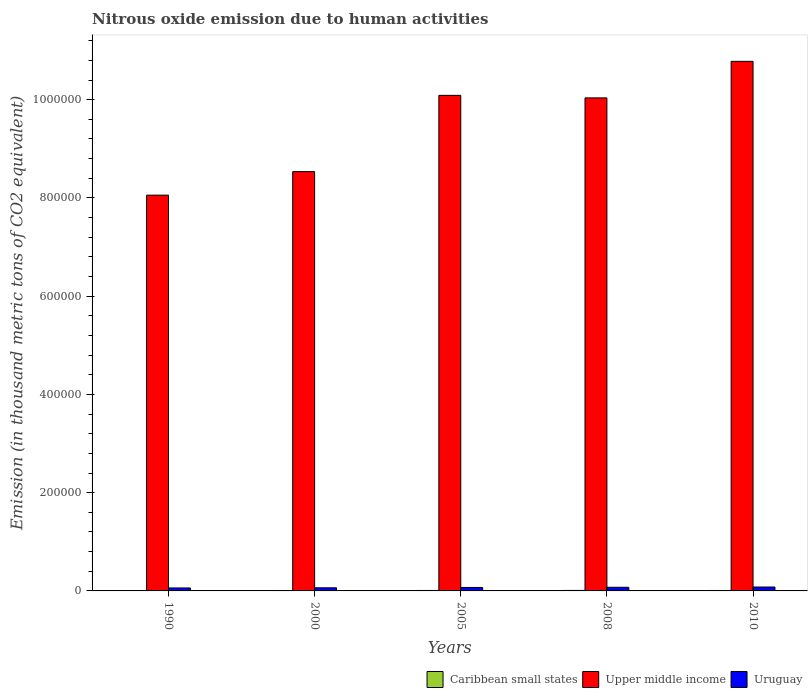How many different coloured bars are there?
Offer a very short reply. 3. How many groups of bars are there?
Your answer should be very brief. 5. Are the number of bars on each tick of the X-axis equal?
Make the answer very short. Yes. How many bars are there on the 5th tick from the left?
Your answer should be very brief. 3. How many bars are there on the 3rd tick from the right?
Offer a very short reply. 3. In how many cases, is the number of bars for a given year not equal to the number of legend labels?
Give a very brief answer. 0. What is the amount of nitrous oxide emitted in Uruguay in 1990?
Your response must be concise. 6054.9. Across all years, what is the maximum amount of nitrous oxide emitted in Uruguay?
Your answer should be compact. 7946.5. Across all years, what is the minimum amount of nitrous oxide emitted in Caribbean small states?
Provide a succinct answer. 699.1. In which year was the amount of nitrous oxide emitted in Uruguay maximum?
Your answer should be compact. 2010. What is the total amount of nitrous oxide emitted in Uruguay in the graph?
Your response must be concise. 3.48e+04. What is the difference between the amount of nitrous oxide emitted in Upper middle income in 1990 and that in 2010?
Offer a very short reply. -2.72e+05. What is the difference between the amount of nitrous oxide emitted in Caribbean small states in 2010 and the amount of nitrous oxide emitted in Upper middle income in 2005?
Keep it short and to the point. -1.01e+06. What is the average amount of nitrous oxide emitted in Caribbean small states per year?
Provide a succinct answer. 882.52. In the year 2005, what is the difference between the amount of nitrous oxide emitted in Caribbean small states and amount of nitrous oxide emitted in Uruguay?
Ensure brevity in your answer.  -6109.6. What is the ratio of the amount of nitrous oxide emitted in Uruguay in 2008 to that in 2010?
Ensure brevity in your answer.  0.93. What is the difference between the highest and the second highest amount of nitrous oxide emitted in Upper middle income?
Your answer should be compact. 6.92e+04. What is the difference between the highest and the lowest amount of nitrous oxide emitted in Upper middle income?
Make the answer very short. 2.72e+05. Is the sum of the amount of nitrous oxide emitted in Uruguay in 1990 and 2010 greater than the maximum amount of nitrous oxide emitted in Caribbean small states across all years?
Offer a very short reply. Yes. What does the 1st bar from the left in 2005 represents?
Give a very brief answer. Caribbean small states. What does the 2nd bar from the right in 2010 represents?
Provide a succinct answer. Upper middle income. How many years are there in the graph?
Give a very brief answer. 5. Are the values on the major ticks of Y-axis written in scientific E-notation?
Give a very brief answer. No. Does the graph contain grids?
Give a very brief answer. No. What is the title of the graph?
Make the answer very short. Nitrous oxide emission due to human activities. What is the label or title of the X-axis?
Your answer should be very brief. Years. What is the label or title of the Y-axis?
Provide a short and direct response. Emission (in thousand metric tons of CO2 equivalent). What is the Emission (in thousand metric tons of CO2 equivalent) of Caribbean small states in 1990?
Your answer should be very brief. 699.1. What is the Emission (in thousand metric tons of CO2 equivalent) of Upper middle income in 1990?
Your answer should be compact. 8.06e+05. What is the Emission (in thousand metric tons of CO2 equivalent) in Uruguay in 1990?
Provide a succinct answer. 6054.9. What is the Emission (in thousand metric tons of CO2 equivalent) of Caribbean small states in 2000?
Provide a short and direct response. 867.7. What is the Emission (in thousand metric tons of CO2 equivalent) in Upper middle income in 2000?
Provide a short and direct response. 8.54e+05. What is the Emission (in thousand metric tons of CO2 equivalent) of Uruguay in 2000?
Give a very brief answer. 6333.8. What is the Emission (in thousand metric tons of CO2 equivalent) of Caribbean small states in 2005?
Ensure brevity in your answer.  923.3. What is the Emission (in thousand metric tons of CO2 equivalent) of Upper middle income in 2005?
Your answer should be very brief. 1.01e+06. What is the Emission (in thousand metric tons of CO2 equivalent) of Uruguay in 2005?
Provide a short and direct response. 7032.9. What is the Emission (in thousand metric tons of CO2 equivalent) of Caribbean small states in 2008?
Give a very brief answer. 1003.4. What is the Emission (in thousand metric tons of CO2 equivalent) in Upper middle income in 2008?
Keep it short and to the point. 1.00e+06. What is the Emission (in thousand metric tons of CO2 equivalent) of Uruguay in 2008?
Your answer should be very brief. 7408. What is the Emission (in thousand metric tons of CO2 equivalent) in Caribbean small states in 2010?
Provide a succinct answer. 919.1. What is the Emission (in thousand metric tons of CO2 equivalent) of Upper middle income in 2010?
Give a very brief answer. 1.08e+06. What is the Emission (in thousand metric tons of CO2 equivalent) of Uruguay in 2010?
Give a very brief answer. 7946.5. Across all years, what is the maximum Emission (in thousand metric tons of CO2 equivalent) of Caribbean small states?
Your answer should be very brief. 1003.4. Across all years, what is the maximum Emission (in thousand metric tons of CO2 equivalent) in Upper middle income?
Ensure brevity in your answer.  1.08e+06. Across all years, what is the maximum Emission (in thousand metric tons of CO2 equivalent) of Uruguay?
Provide a succinct answer. 7946.5. Across all years, what is the minimum Emission (in thousand metric tons of CO2 equivalent) of Caribbean small states?
Keep it short and to the point. 699.1. Across all years, what is the minimum Emission (in thousand metric tons of CO2 equivalent) in Upper middle income?
Your response must be concise. 8.06e+05. Across all years, what is the minimum Emission (in thousand metric tons of CO2 equivalent) in Uruguay?
Provide a succinct answer. 6054.9. What is the total Emission (in thousand metric tons of CO2 equivalent) in Caribbean small states in the graph?
Provide a succinct answer. 4412.6. What is the total Emission (in thousand metric tons of CO2 equivalent) of Upper middle income in the graph?
Provide a short and direct response. 4.75e+06. What is the total Emission (in thousand metric tons of CO2 equivalent) in Uruguay in the graph?
Your answer should be very brief. 3.48e+04. What is the difference between the Emission (in thousand metric tons of CO2 equivalent) in Caribbean small states in 1990 and that in 2000?
Provide a short and direct response. -168.6. What is the difference between the Emission (in thousand metric tons of CO2 equivalent) in Upper middle income in 1990 and that in 2000?
Keep it short and to the point. -4.79e+04. What is the difference between the Emission (in thousand metric tons of CO2 equivalent) in Uruguay in 1990 and that in 2000?
Your answer should be compact. -278.9. What is the difference between the Emission (in thousand metric tons of CO2 equivalent) of Caribbean small states in 1990 and that in 2005?
Make the answer very short. -224.2. What is the difference between the Emission (in thousand metric tons of CO2 equivalent) in Upper middle income in 1990 and that in 2005?
Offer a very short reply. -2.03e+05. What is the difference between the Emission (in thousand metric tons of CO2 equivalent) of Uruguay in 1990 and that in 2005?
Your response must be concise. -978. What is the difference between the Emission (in thousand metric tons of CO2 equivalent) in Caribbean small states in 1990 and that in 2008?
Provide a short and direct response. -304.3. What is the difference between the Emission (in thousand metric tons of CO2 equivalent) in Upper middle income in 1990 and that in 2008?
Keep it short and to the point. -1.98e+05. What is the difference between the Emission (in thousand metric tons of CO2 equivalent) of Uruguay in 1990 and that in 2008?
Keep it short and to the point. -1353.1. What is the difference between the Emission (in thousand metric tons of CO2 equivalent) in Caribbean small states in 1990 and that in 2010?
Your answer should be compact. -220. What is the difference between the Emission (in thousand metric tons of CO2 equivalent) in Upper middle income in 1990 and that in 2010?
Offer a very short reply. -2.72e+05. What is the difference between the Emission (in thousand metric tons of CO2 equivalent) in Uruguay in 1990 and that in 2010?
Give a very brief answer. -1891.6. What is the difference between the Emission (in thousand metric tons of CO2 equivalent) in Caribbean small states in 2000 and that in 2005?
Give a very brief answer. -55.6. What is the difference between the Emission (in thousand metric tons of CO2 equivalent) in Upper middle income in 2000 and that in 2005?
Provide a succinct answer. -1.55e+05. What is the difference between the Emission (in thousand metric tons of CO2 equivalent) in Uruguay in 2000 and that in 2005?
Provide a short and direct response. -699.1. What is the difference between the Emission (in thousand metric tons of CO2 equivalent) in Caribbean small states in 2000 and that in 2008?
Keep it short and to the point. -135.7. What is the difference between the Emission (in thousand metric tons of CO2 equivalent) in Upper middle income in 2000 and that in 2008?
Your answer should be very brief. -1.50e+05. What is the difference between the Emission (in thousand metric tons of CO2 equivalent) of Uruguay in 2000 and that in 2008?
Make the answer very short. -1074.2. What is the difference between the Emission (in thousand metric tons of CO2 equivalent) in Caribbean small states in 2000 and that in 2010?
Your response must be concise. -51.4. What is the difference between the Emission (in thousand metric tons of CO2 equivalent) of Upper middle income in 2000 and that in 2010?
Your answer should be very brief. -2.24e+05. What is the difference between the Emission (in thousand metric tons of CO2 equivalent) in Uruguay in 2000 and that in 2010?
Give a very brief answer. -1612.7. What is the difference between the Emission (in thousand metric tons of CO2 equivalent) of Caribbean small states in 2005 and that in 2008?
Keep it short and to the point. -80.1. What is the difference between the Emission (in thousand metric tons of CO2 equivalent) in Upper middle income in 2005 and that in 2008?
Your response must be concise. 5159.9. What is the difference between the Emission (in thousand metric tons of CO2 equivalent) in Uruguay in 2005 and that in 2008?
Your answer should be very brief. -375.1. What is the difference between the Emission (in thousand metric tons of CO2 equivalent) of Upper middle income in 2005 and that in 2010?
Your answer should be compact. -6.92e+04. What is the difference between the Emission (in thousand metric tons of CO2 equivalent) in Uruguay in 2005 and that in 2010?
Ensure brevity in your answer.  -913.6. What is the difference between the Emission (in thousand metric tons of CO2 equivalent) of Caribbean small states in 2008 and that in 2010?
Your answer should be compact. 84.3. What is the difference between the Emission (in thousand metric tons of CO2 equivalent) of Upper middle income in 2008 and that in 2010?
Provide a short and direct response. -7.44e+04. What is the difference between the Emission (in thousand metric tons of CO2 equivalent) of Uruguay in 2008 and that in 2010?
Offer a very short reply. -538.5. What is the difference between the Emission (in thousand metric tons of CO2 equivalent) in Caribbean small states in 1990 and the Emission (in thousand metric tons of CO2 equivalent) in Upper middle income in 2000?
Keep it short and to the point. -8.53e+05. What is the difference between the Emission (in thousand metric tons of CO2 equivalent) in Caribbean small states in 1990 and the Emission (in thousand metric tons of CO2 equivalent) in Uruguay in 2000?
Make the answer very short. -5634.7. What is the difference between the Emission (in thousand metric tons of CO2 equivalent) of Upper middle income in 1990 and the Emission (in thousand metric tons of CO2 equivalent) of Uruguay in 2000?
Your response must be concise. 7.99e+05. What is the difference between the Emission (in thousand metric tons of CO2 equivalent) in Caribbean small states in 1990 and the Emission (in thousand metric tons of CO2 equivalent) in Upper middle income in 2005?
Offer a very short reply. -1.01e+06. What is the difference between the Emission (in thousand metric tons of CO2 equivalent) in Caribbean small states in 1990 and the Emission (in thousand metric tons of CO2 equivalent) in Uruguay in 2005?
Your response must be concise. -6333.8. What is the difference between the Emission (in thousand metric tons of CO2 equivalent) in Upper middle income in 1990 and the Emission (in thousand metric tons of CO2 equivalent) in Uruguay in 2005?
Your answer should be very brief. 7.99e+05. What is the difference between the Emission (in thousand metric tons of CO2 equivalent) of Caribbean small states in 1990 and the Emission (in thousand metric tons of CO2 equivalent) of Upper middle income in 2008?
Your answer should be compact. -1.00e+06. What is the difference between the Emission (in thousand metric tons of CO2 equivalent) in Caribbean small states in 1990 and the Emission (in thousand metric tons of CO2 equivalent) in Uruguay in 2008?
Provide a succinct answer. -6708.9. What is the difference between the Emission (in thousand metric tons of CO2 equivalent) in Upper middle income in 1990 and the Emission (in thousand metric tons of CO2 equivalent) in Uruguay in 2008?
Your response must be concise. 7.98e+05. What is the difference between the Emission (in thousand metric tons of CO2 equivalent) in Caribbean small states in 1990 and the Emission (in thousand metric tons of CO2 equivalent) in Upper middle income in 2010?
Provide a succinct answer. -1.08e+06. What is the difference between the Emission (in thousand metric tons of CO2 equivalent) of Caribbean small states in 1990 and the Emission (in thousand metric tons of CO2 equivalent) of Uruguay in 2010?
Provide a succinct answer. -7247.4. What is the difference between the Emission (in thousand metric tons of CO2 equivalent) in Upper middle income in 1990 and the Emission (in thousand metric tons of CO2 equivalent) in Uruguay in 2010?
Keep it short and to the point. 7.98e+05. What is the difference between the Emission (in thousand metric tons of CO2 equivalent) in Caribbean small states in 2000 and the Emission (in thousand metric tons of CO2 equivalent) in Upper middle income in 2005?
Offer a very short reply. -1.01e+06. What is the difference between the Emission (in thousand metric tons of CO2 equivalent) of Caribbean small states in 2000 and the Emission (in thousand metric tons of CO2 equivalent) of Uruguay in 2005?
Provide a succinct answer. -6165.2. What is the difference between the Emission (in thousand metric tons of CO2 equivalent) in Upper middle income in 2000 and the Emission (in thousand metric tons of CO2 equivalent) in Uruguay in 2005?
Keep it short and to the point. 8.47e+05. What is the difference between the Emission (in thousand metric tons of CO2 equivalent) in Caribbean small states in 2000 and the Emission (in thousand metric tons of CO2 equivalent) in Upper middle income in 2008?
Your answer should be very brief. -1.00e+06. What is the difference between the Emission (in thousand metric tons of CO2 equivalent) in Caribbean small states in 2000 and the Emission (in thousand metric tons of CO2 equivalent) in Uruguay in 2008?
Provide a short and direct response. -6540.3. What is the difference between the Emission (in thousand metric tons of CO2 equivalent) in Upper middle income in 2000 and the Emission (in thousand metric tons of CO2 equivalent) in Uruguay in 2008?
Provide a short and direct response. 8.46e+05. What is the difference between the Emission (in thousand metric tons of CO2 equivalent) of Caribbean small states in 2000 and the Emission (in thousand metric tons of CO2 equivalent) of Upper middle income in 2010?
Your response must be concise. -1.08e+06. What is the difference between the Emission (in thousand metric tons of CO2 equivalent) in Caribbean small states in 2000 and the Emission (in thousand metric tons of CO2 equivalent) in Uruguay in 2010?
Your answer should be very brief. -7078.8. What is the difference between the Emission (in thousand metric tons of CO2 equivalent) in Upper middle income in 2000 and the Emission (in thousand metric tons of CO2 equivalent) in Uruguay in 2010?
Give a very brief answer. 8.46e+05. What is the difference between the Emission (in thousand metric tons of CO2 equivalent) in Caribbean small states in 2005 and the Emission (in thousand metric tons of CO2 equivalent) in Upper middle income in 2008?
Provide a succinct answer. -1.00e+06. What is the difference between the Emission (in thousand metric tons of CO2 equivalent) in Caribbean small states in 2005 and the Emission (in thousand metric tons of CO2 equivalent) in Uruguay in 2008?
Your answer should be compact. -6484.7. What is the difference between the Emission (in thousand metric tons of CO2 equivalent) in Upper middle income in 2005 and the Emission (in thousand metric tons of CO2 equivalent) in Uruguay in 2008?
Provide a short and direct response. 1.00e+06. What is the difference between the Emission (in thousand metric tons of CO2 equivalent) in Caribbean small states in 2005 and the Emission (in thousand metric tons of CO2 equivalent) in Upper middle income in 2010?
Your answer should be very brief. -1.08e+06. What is the difference between the Emission (in thousand metric tons of CO2 equivalent) in Caribbean small states in 2005 and the Emission (in thousand metric tons of CO2 equivalent) in Uruguay in 2010?
Make the answer very short. -7023.2. What is the difference between the Emission (in thousand metric tons of CO2 equivalent) in Upper middle income in 2005 and the Emission (in thousand metric tons of CO2 equivalent) in Uruguay in 2010?
Keep it short and to the point. 1.00e+06. What is the difference between the Emission (in thousand metric tons of CO2 equivalent) of Caribbean small states in 2008 and the Emission (in thousand metric tons of CO2 equivalent) of Upper middle income in 2010?
Offer a very short reply. -1.08e+06. What is the difference between the Emission (in thousand metric tons of CO2 equivalent) in Caribbean small states in 2008 and the Emission (in thousand metric tons of CO2 equivalent) in Uruguay in 2010?
Ensure brevity in your answer.  -6943.1. What is the difference between the Emission (in thousand metric tons of CO2 equivalent) in Upper middle income in 2008 and the Emission (in thousand metric tons of CO2 equivalent) in Uruguay in 2010?
Your answer should be very brief. 9.96e+05. What is the average Emission (in thousand metric tons of CO2 equivalent) of Caribbean small states per year?
Keep it short and to the point. 882.52. What is the average Emission (in thousand metric tons of CO2 equivalent) in Upper middle income per year?
Offer a terse response. 9.50e+05. What is the average Emission (in thousand metric tons of CO2 equivalent) of Uruguay per year?
Offer a terse response. 6955.22. In the year 1990, what is the difference between the Emission (in thousand metric tons of CO2 equivalent) of Caribbean small states and Emission (in thousand metric tons of CO2 equivalent) of Upper middle income?
Your answer should be compact. -8.05e+05. In the year 1990, what is the difference between the Emission (in thousand metric tons of CO2 equivalent) of Caribbean small states and Emission (in thousand metric tons of CO2 equivalent) of Uruguay?
Keep it short and to the point. -5355.8. In the year 1990, what is the difference between the Emission (in thousand metric tons of CO2 equivalent) in Upper middle income and Emission (in thousand metric tons of CO2 equivalent) in Uruguay?
Keep it short and to the point. 8.00e+05. In the year 2000, what is the difference between the Emission (in thousand metric tons of CO2 equivalent) of Caribbean small states and Emission (in thousand metric tons of CO2 equivalent) of Upper middle income?
Give a very brief answer. -8.53e+05. In the year 2000, what is the difference between the Emission (in thousand metric tons of CO2 equivalent) of Caribbean small states and Emission (in thousand metric tons of CO2 equivalent) of Uruguay?
Provide a succinct answer. -5466.1. In the year 2000, what is the difference between the Emission (in thousand metric tons of CO2 equivalent) of Upper middle income and Emission (in thousand metric tons of CO2 equivalent) of Uruguay?
Your response must be concise. 8.47e+05. In the year 2005, what is the difference between the Emission (in thousand metric tons of CO2 equivalent) in Caribbean small states and Emission (in thousand metric tons of CO2 equivalent) in Upper middle income?
Offer a very short reply. -1.01e+06. In the year 2005, what is the difference between the Emission (in thousand metric tons of CO2 equivalent) of Caribbean small states and Emission (in thousand metric tons of CO2 equivalent) of Uruguay?
Ensure brevity in your answer.  -6109.6. In the year 2005, what is the difference between the Emission (in thousand metric tons of CO2 equivalent) of Upper middle income and Emission (in thousand metric tons of CO2 equivalent) of Uruguay?
Ensure brevity in your answer.  1.00e+06. In the year 2008, what is the difference between the Emission (in thousand metric tons of CO2 equivalent) in Caribbean small states and Emission (in thousand metric tons of CO2 equivalent) in Upper middle income?
Offer a very short reply. -1.00e+06. In the year 2008, what is the difference between the Emission (in thousand metric tons of CO2 equivalent) in Caribbean small states and Emission (in thousand metric tons of CO2 equivalent) in Uruguay?
Offer a terse response. -6404.6. In the year 2008, what is the difference between the Emission (in thousand metric tons of CO2 equivalent) of Upper middle income and Emission (in thousand metric tons of CO2 equivalent) of Uruguay?
Your response must be concise. 9.96e+05. In the year 2010, what is the difference between the Emission (in thousand metric tons of CO2 equivalent) of Caribbean small states and Emission (in thousand metric tons of CO2 equivalent) of Upper middle income?
Your response must be concise. -1.08e+06. In the year 2010, what is the difference between the Emission (in thousand metric tons of CO2 equivalent) in Caribbean small states and Emission (in thousand metric tons of CO2 equivalent) in Uruguay?
Offer a very short reply. -7027.4. In the year 2010, what is the difference between the Emission (in thousand metric tons of CO2 equivalent) in Upper middle income and Emission (in thousand metric tons of CO2 equivalent) in Uruguay?
Your response must be concise. 1.07e+06. What is the ratio of the Emission (in thousand metric tons of CO2 equivalent) in Caribbean small states in 1990 to that in 2000?
Ensure brevity in your answer.  0.81. What is the ratio of the Emission (in thousand metric tons of CO2 equivalent) in Upper middle income in 1990 to that in 2000?
Give a very brief answer. 0.94. What is the ratio of the Emission (in thousand metric tons of CO2 equivalent) in Uruguay in 1990 to that in 2000?
Offer a very short reply. 0.96. What is the ratio of the Emission (in thousand metric tons of CO2 equivalent) in Caribbean small states in 1990 to that in 2005?
Your response must be concise. 0.76. What is the ratio of the Emission (in thousand metric tons of CO2 equivalent) of Upper middle income in 1990 to that in 2005?
Your answer should be compact. 0.8. What is the ratio of the Emission (in thousand metric tons of CO2 equivalent) in Uruguay in 1990 to that in 2005?
Offer a very short reply. 0.86. What is the ratio of the Emission (in thousand metric tons of CO2 equivalent) in Caribbean small states in 1990 to that in 2008?
Provide a short and direct response. 0.7. What is the ratio of the Emission (in thousand metric tons of CO2 equivalent) of Upper middle income in 1990 to that in 2008?
Give a very brief answer. 0.8. What is the ratio of the Emission (in thousand metric tons of CO2 equivalent) in Uruguay in 1990 to that in 2008?
Make the answer very short. 0.82. What is the ratio of the Emission (in thousand metric tons of CO2 equivalent) in Caribbean small states in 1990 to that in 2010?
Your response must be concise. 0.76. What is the ratio of the Emission (in thousand metric tons of CO2 equivalent) of Upper middle income in 1990 to that in 2010?
Provide a short and direct response. 0.75. What is the ratio of the Emission (in thousand metric tons of CO2 equivalent) of Uruguay in 1990 to that in 2010?
Keep it short and to the point. 0.76. What is the ratio of the Emission (in thousand metric tons of CO2 equivalent) in Caribbean small states in 2000 to that in 2005?
Make the answer very short. 0.94. What is the ratio of the Emission (in thousand metric tons of CO2 equivalent) of Upper middle income in 2000 to that in 2005?
Your answer should be very brief. 0.85. What is the ratio of the Emission (in thousand metric tons of CO2 equivalent) in Uruguay in 2000 to that in 2005?
Give a very brief answer. 0.9. What is the ratio of the Emission (in thousand metric tons of CO2 equivalent) in Caribbean small states in 2000 to that in 2008?
Give a very brief answer. 0.86. What is the ratio of the Emission (in thousand metric tons of CO2 equivalent) in Upper middle income in 2000 to that in 2008?
Your response must be concise. 0.85. What is the ratio of the Emission (in thousand metric tons of CO2 equivalent) of Uruguay in 2000 to that in 2008?
Make the answer very short. 0.85. What is the ratio of the Emission (in thousand metric tons of CO2 equivalent) of Caribbean small states in 2000 to that in 2010?
Ensure brevity in your answer.  0.94. What is the ratio of the Emission (in thousand metric tons of CO2 equivalent) of Upper middle income in 2000 to that in 2010?
Make the answer very short. 0.79. What is the ratio of the Emission (in thousand metric tons of CO2 equivalent) in Uruguay in 2000 to that in 2010?
Make the answer very short. 0.8. What is the ratio of the Emission (in thousand metric tons of CO2 equivalent) in Caribbean small states in 2005 to that in 2008?
Your response must be concise. 0.92. What is the ratio of the Emission (in thousand metric tons of CO2 equivalent) of Upper middle income in 2005 to that in 2008?
Offer a terse response. 1.01. What is the ratio of the Emission (in thousand metric tons of CO2 equivalent) in Uruguay in 2005 to that in 2008?
Provide a short and direct response. 0.95. What is the ratio of the Emission (in thousand metric tons of CO2 equivalent) of Upper middle income in 2005 to that in 2010?
Ensure brevity in your answer.  0.94. What is the ratio of the Emission (in thousand metric tons of CO2 equivalent) of Uruguay in 2005 to that in 2010?
Your answer should be compact. 0.89. What is the ratio of the Emission (in thousand metric tons of CO2 equivalent) of Caribbean small states in 2008 to that in 2010?
Offer a very short reply. 1.09. What is the ratio of the Emission (in thousand metric tons of CO2 equivalent) of Upper middle income in 2008 to that in 2010?
Offer a terse response. 0.93. What is the ratio of the Emission (in thousand metric tons of CO2 equivalent) of Uruguay in 2008 to that in 2010?
Ensure brevity in your answer.  0.93. What is the difference between the highest and the second highest Emission (in thousand metric tons of CO2 equivalent) of Caribbean small states?
Your response must be concise. 80.1. What is the difference between the highest and the second highest Emission (in thousand metric tons of CO2 equivalent) in Upper middle income?
Keep it short and to the point. 6.92e+04. What is the difference between the highest and the second highest Emission (in thousand metric tons of CO2 equivalent) in Uruguay?
Your answer should be compact. 538.5. What is the difference between the highest and the lowest Emission (in thousand metric tons of CO2 equivalent) of Caribbean small states?
Keep it short and to the point. 304.3. What is the difference between the highest and the lowest Emission (in thousand metric tons of CO2 equivalent) of Upper middle income?
Provide a succinct answer. 2.72e+05. What is the difference between the highest and the lowest Emission (in thousand metric tons of CO2 equivalent) in Uruguay?
Your answer should be compact. 1891.6. 